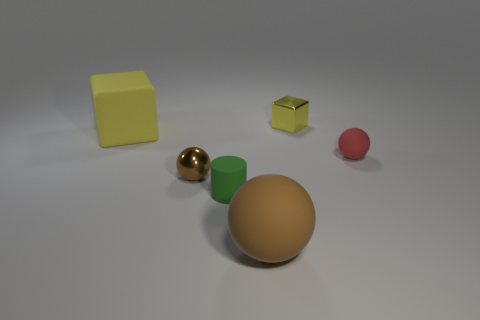Subtract all tiny balls. How many balls are left? 1 Subtract 1 spheres. How many spheres are left? 2 Add 1 big yellow matte blocks. How many objects exist? 7 Subtract all cylinders. How many objects are left? 5 Add 3 green things. How many green things are left? 4 Add 5 rubber cylinders. How many rubber cylinders exist? 6 Subtract 0 green blocks. How many objects are left? 6 Subtract all tiny brown shiny cylinders. Subtract all tiny green matte cylinders. How many objects are left? 5 